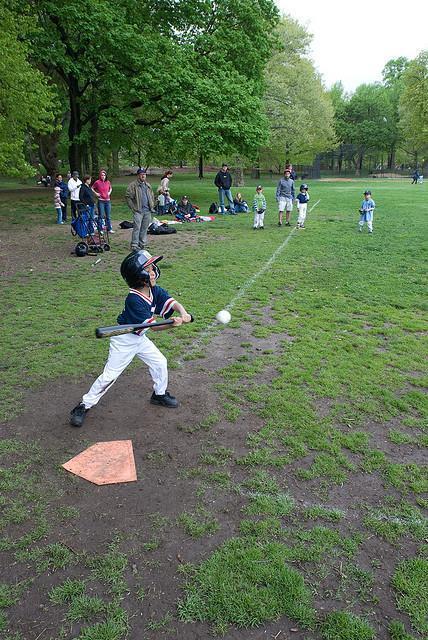How many people are there?
Give a very brief answer. 2. How many dogs are on the bed?
Give a very brief answer. 0. 